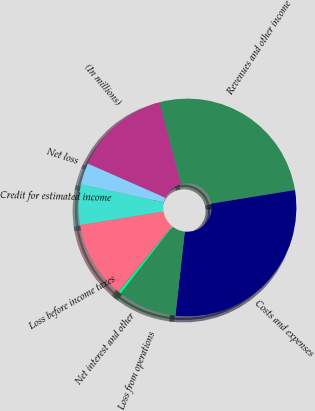Convert chart to OTSL. <chart><loc_0><loc_0><loc_500><loc_500><pie_chart><fcel>(In millions)<fcel>Revenues and other income<fcel>Costs and expenses<fcel>Loss from operations<fcel>Net interest and other<fcel>Loss before income taxes<fcel>Credit for estimated income<fcel>Net loss<nl><fcel>14.28%<fcel>26.56%<fcel>29.33%<fcel>8.74%<fcel>0.42%<fcel>11.51%<fcel>5.97%<fcel>3.19%<nl></chart> 